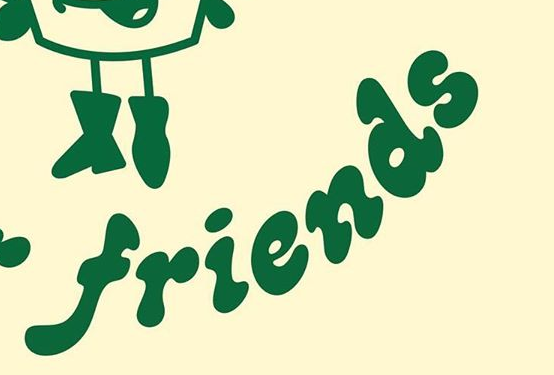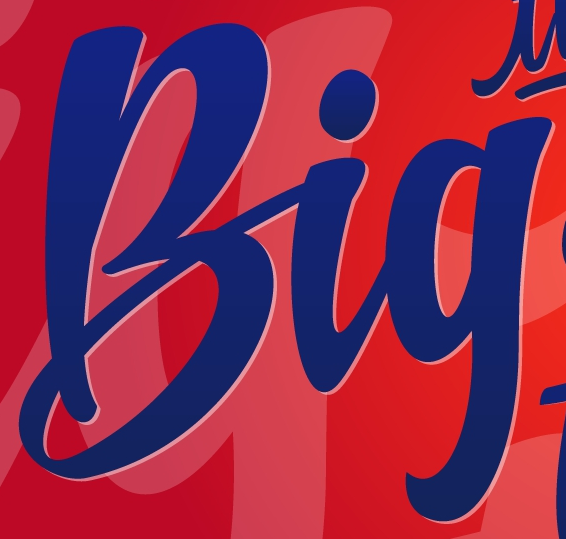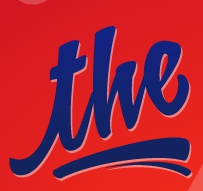Transcribe the words shown in these images in order, separated by a semicolon. friends; Big; the 